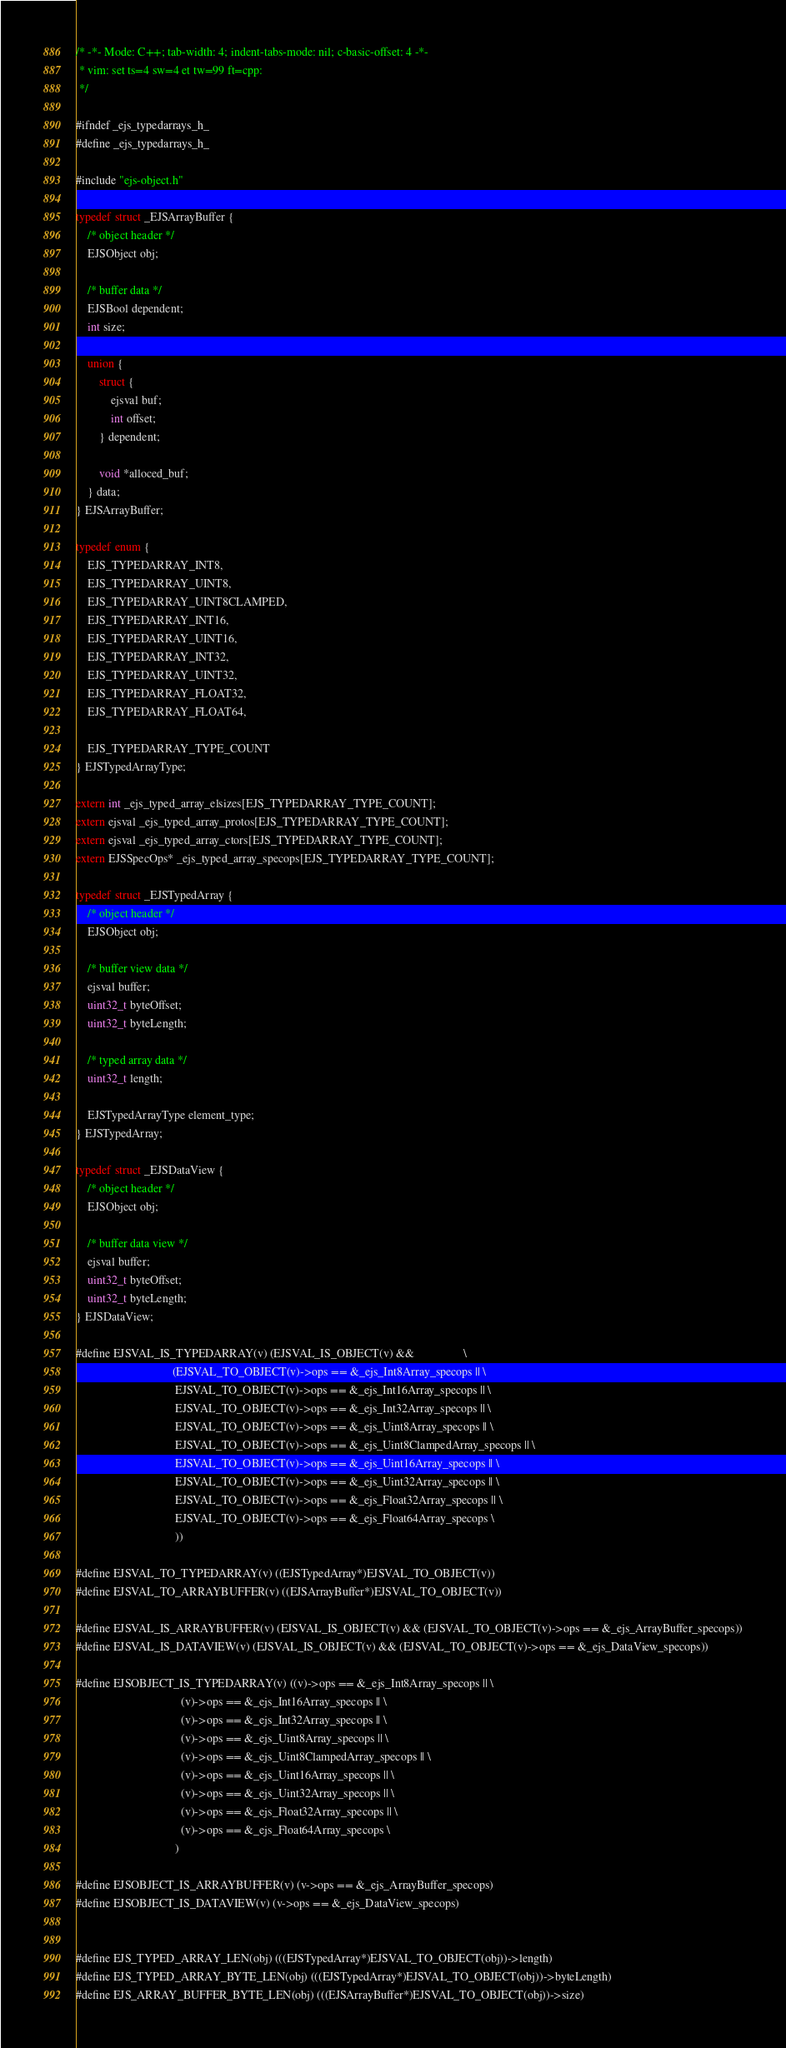Convert code to text. <code><loc_0><loc_0><loc_500><loc_500><_C_>/* -*- Mode: C++; tab-width: 4; indent-tabs-mode: nil; c-basic-offset: 4 -*-
 * vim: set ts=4 sw=4 et tw=99 ft=cpp:
 */

#ifndef _ejs_typedarrays_h_
#define _ejs_typedarrays_h_

#include "ejs-object.h"

typedef struct _EJSArrayBuffer {
    /* object header */
    EJSObject obj;

    /* buffer data */
    EJSBool dependent;
    int size;

    union {
        struct {
            ejsval buf;
            int offset;
        } dependent;

        void *alloced_buf;
    } data;
} EJSArrayBuffer;

typedef enum {
    EJS_TYPEDARRAY_INT8,
    EJS_TYPEDARRAY_UINT8,
    EJS_TYPEDARRAY_UINT8CLAMPED,
    EJS_TYPEDARRAY_INT16,
    EJS_TYPEDARRAY_UINT16,
    EJS_TYPEDARRAY_INT32,
    EJS_TYPEDARRAY_UINT32,
    EJS_TYPEDARRAY_FLOAT32,
    EJS_TYPEDARRAY_FLOAT64,

    EJS_TYPEDARRAY_TYPE_COUNT
} EJSTypedArrayType;

extern int _ejs_typed_array_elsizes[EJS_TYPEDARRAY_TYPE_COUNT];
extern ejsval _ejs_typed_array_protos[EJS_TYPEDARRAY_TYPE_COUNT];
extern ejsval _ejs_typed_array_ctors[EJS_TYPEDARRAY_TYPE_COUNT];
extern EJSSpecOps* _ejs_typed_array_specops[EJS_TYPEDARRAY_TYPE_COUNT];

typedef struct _EJSTypedArray {
    /* object header */
    EJSObject obj;

    /* buffer view data */
    ejsval buffer;
    uint32_t byteOffset;
    uint32_t byteLength;

    /* typed array data */
    uint32_t length;

    EJSTypedArrayType element_type;
} EJSTypedArray;

typedef struct _EJSDataView {
    /* object header */
    EJSObject obj;

    /* buffer data view */
    ejsval buffer;
    uint32_t byteOffset;
    uint32_t byteLength;
} EJSDataView;

#define EJSVAL_IS_TYPEDARRAY(v) (EJSVAL_IS_OBJECT(v) &&                 \
                                 (EJSVAL_TO_OBJECT(v)->ops == &_ejs_Int8Array_specops || \
                                  EJSVAL_TO_OBJECT(v)->ops == &_ejs_Int16Array_specops || \
                                  EJSVAL_TO_OBJECT(v)->ops == &_ejs_Int32Array_specops || \
                                  EJSVAL_TO_OBJECT(v)->ops == &_ejs_Uint8Array_specops || \
                                  EJSVAL_TO_OBJECT(v)->ops == &_ejs_Uint8ClampedArray_specops || \
                                  EJSVAL_TO_OBJECT(v)->ops == &_ejs_Uint16Array_specops || \
                                  EJSVAL_TO_OBJECT(v)->ops == &_ejs_Uint32Array_specops || \
                                  EJSVAL_TO_OBJECT(v)->ops == &_ejs_Float32Array_specops || \
                                  EJSVAL_TO_OBJECT(v)->ops == &_ejs_Float64Array_specops \
                                  ))

#define EJSVAL_TO_TYPEDARRAY(v) ((EJSTypedArray*)EJSVAL_TO_OBJECT(v))
#define EJSVAL_TO_ARRAYBUFFER(v) ((EJSArrayBuffer*)EJSVAL_TO_OBJECT(v))

#define EJSVAL_IS_ARRAYBUFFER(v) (EJSVAL_IS_OBJECT(v) && (EJSVAL_TO_OBJECT(v)->ops == &_ejs_ArrayBuffer_specops))
#define EJSVAL_IS_DATAVIEW(v) (EJSVAL_IS_OBJECT(v) && (EJSVAL_TO_OBJECT(v)->ops == &_ejs_DataView_specops))

#define EJSOBJECT_IS_TYPEDARRAY(v) ((v)->ops == &_ejs_Int8Array_specops || \
                                    (v)->ops == &_ejs_Int16Array_specops || \
                                    (v)->ops == &_ejs_Int32Array_specops || \
                                    (v)->ops == &_ejs_Uint8Array_specops || \
                                    (v)->ops == &_ejs_Uint8ClampedArray_specops || \
                                    (v)->ops == &_ejs_Uint16Array_specops || \
                                    (v)->ops == &_ejs_Uint32Array_specops || \
                                    (v)->ops == &_ejs_Float32Array_specops || \
                                    (v)->ops == &_ejs_Float64Array_specops \
                                  )

#define EJSOBJECT_IS_ARRAYBUFFER(v) (v->ops == &_ejs_ArrayBuffer_specops)
#define EJSOBJECT_IS_DATAVIEW(v) (v->ops == &_ejs_DataView_specops)


#define EJS_TYPED_ARRAY_LEN(obj) (((EJSTypedArray*)EJSVAL_TO_OBJECT(obj))->length)
#define EJS_TYPED_ARRAY_BYTE_LEN(obj) (((EJSTypedArray*)EJSVAL_TO_OBJECT(obj))->byteLength)
#define EJS_ARRAY_BUFFER_BYTE_LEN(obj) (((EJSArrayBuffer*)EJSVAL_TO_OBJECT(obj))->size)</code> 